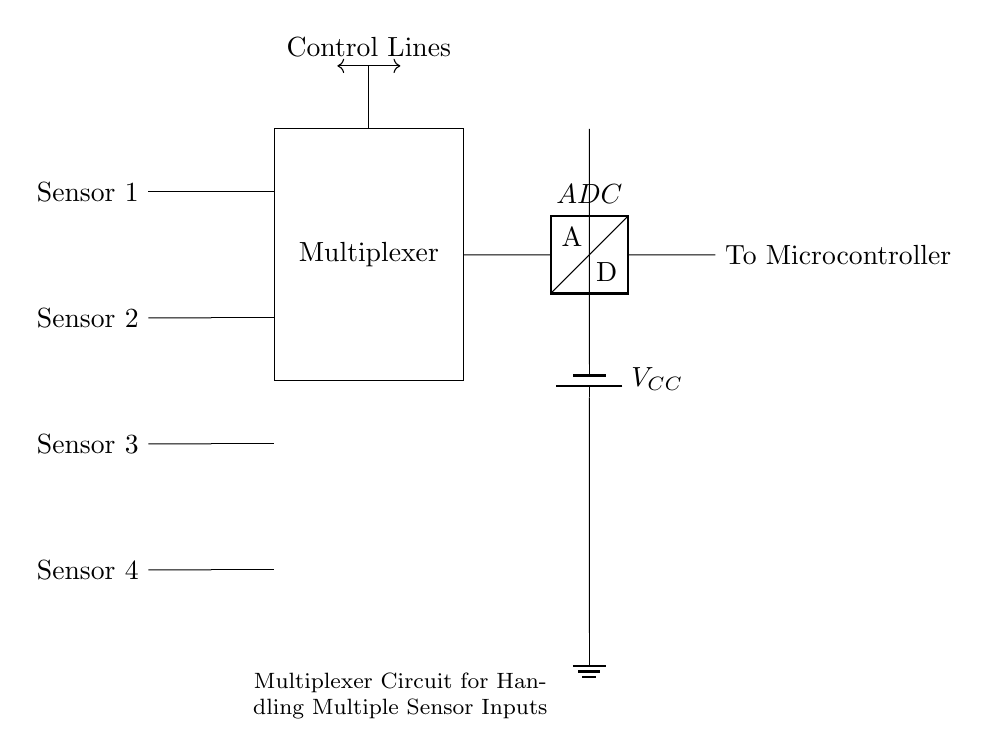What are the components of this circuit? The circuit includes four sensors, a multiplexer, control lines, an ADC, and a power supply. Each component serves a specific function, where the sensors input data, the multiplexer selects between these inputs, the ADC converts the signal, and the power supply provides the necessary voltage for operation.
Answer: sensors, multiplexer, control lines, ADC, power supply How many sensor inputs are connected to the multiplexer? There are four sensor inputs connected to the multiplexer, as indicated by the four lines leading into the multiplexer from the sensor blocks in the diagram. Each line represents a separate sensor's output being routed to the multiplexer.
Answer: four What is the role of the control lines? The control lines determine which sensor's input is being routed through the multiplexer to the ADC. By changing the state of the control lines, different sensor outputs can be selected for further processing, making it a crucial part of the multiplexer operation.
Answer: selection What type of signals do the sensors output? The sensors typically output analog signals, which are continuous signals representing the measured physical quantities. This type of output is suitable for conversion by the ADC after being selected by the multiplexer.
Answer: analog What happens to the selected sensor output after the multiplexer? The selected sensor output is fed into the ADC, which converts the analog signal from the sensor into a digital signal that can be processed by the microcontroller. This conversion is essential for digital data processing in typical experimental setups.
Answer: conversion What is the purpose of the ADC in this circuit? The purpose of the ADC is to convert the selected analog voltage signal from the multiplexer into a digital representation that can be understood and processed by the microcontroller, facilitating data analysis in experimental setups.
Answer: conversion 